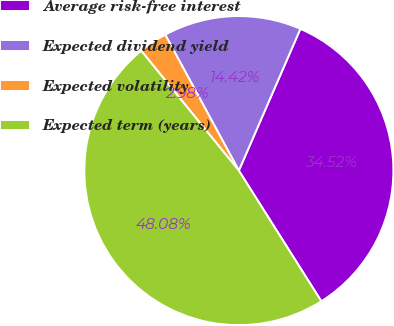Convert chart to OTSL. <chart><loc_0><loc_0><loc_500><loc_500><pie_chart><fcel>Average risk-free interest<fcel>Expected dividend yield<fcel>Expected volatility<fcel>Expected term (years)<nl><fcel>34.52%<fcel>14.42%<fcel>2.98%<fcel>48.08%<nl></chart> 